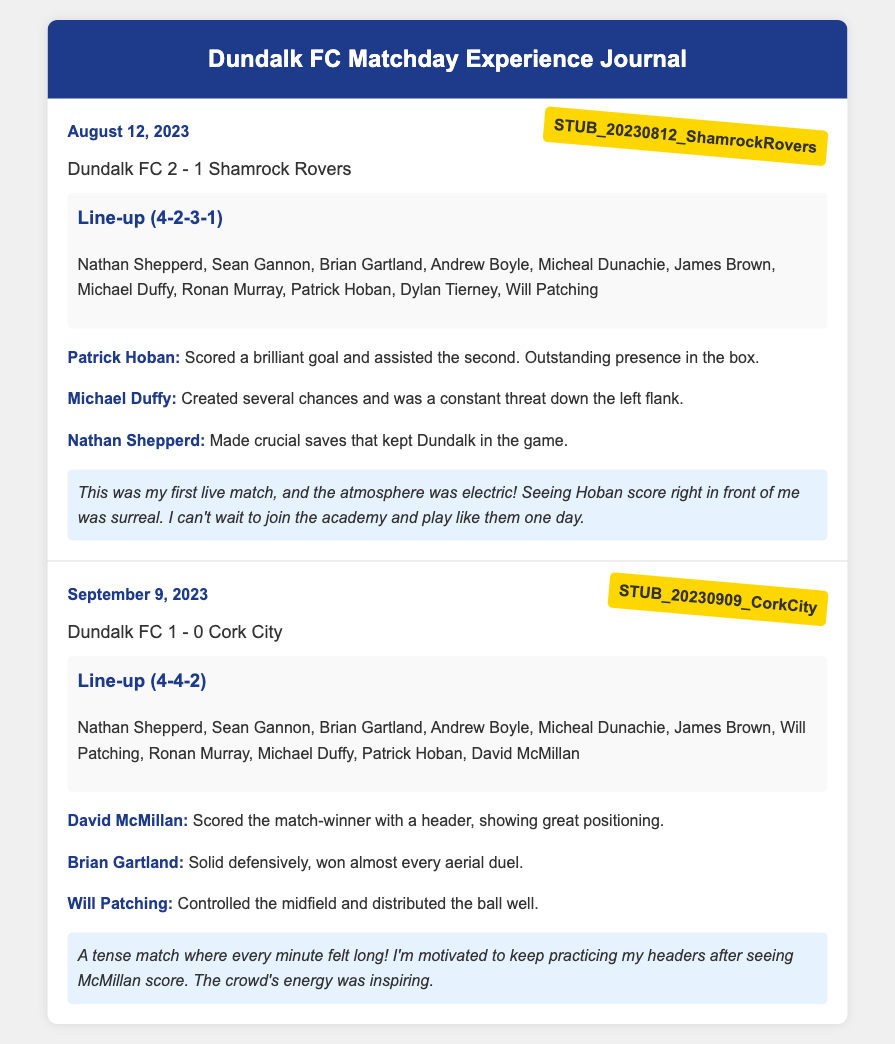What was the result of the match on August 12, 2023? The result of the match is stated as "Dundalk FC 2 - 1 Shamrock Rovers."
Answer: Dundalk FC 2 - 1 Shamrock Rovers Who scored the match-winner against Cork City? The player who scored the match-winner is identified as "David McMillan."
Answer: David McMillan What formation did Dundalk FC use against Shamrock Rovers? The formation used is noted as "4-2-3-1."
Answer: 4-2-3-1 What was the date of the match against Cork City? The date of the match is provided as "September 9, 2023."
Answer: September 9, 2023 Which player was described as having an outstanding presence in the box? The player described with this quality is "Patrick Hoban."
Answer: Patrick Hoban What emotions did the author express about their first live match experience? The author mentions feeling that "the atmosphere was electric!"
Answer: the atmosphere was electric! What was a significant action performed by Nathan Shepperd in the match against Shamrock Rovers? Nathan Shepperd made "crucial saves that kept Dundalk in the game."
Answer: crucial saves What reflection did the author have about practicing headers? The author stated they were "motivated to keep practicing my headers."
Answer: motivated to keep practicing my headers What is included in the game entries besides player performances? The game entries also include "ticket stubs, line-up cards, and personal reflections."
Answer: ticket stubs, line-up cards, and personal reflections 